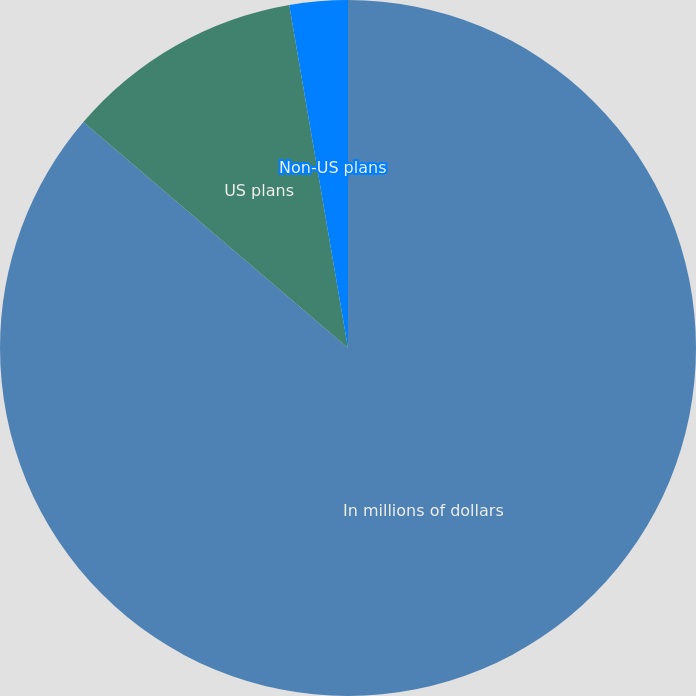Convert chart to OTSL. <chart><loc_0><loc_0><loc_500><loc_500><pie_chart><fcel>In millions of dollars<fcel>US plans<fcel>Non-US plans<nl><fcel>86.25%<fcel>11.05%<fcel>2.7%<nl></chart> 